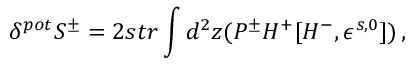<formula> <loc_0><loc_0><loc_500><loc_500>\delta ^ { p o t } S ^ { \pm } = 2 s t r \int d ^ { 2 } z ( P ^ { \pm } H ^ { + } [ H ^ { - } , \epsilon ^ { s , 0 } ] ) \, ,</formula> 